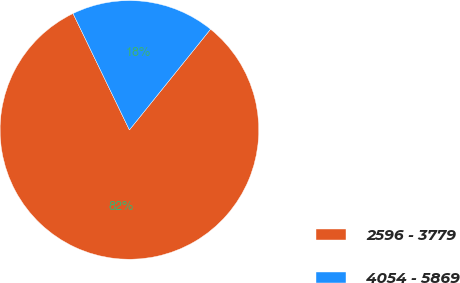Convert chart. <chart><loc_0><loc_0><loc_500><loc_500><pie_chart><fcel>2596 - 3779<fcel>4054 - 5869<nl><fcel>82.03%<fcel>17.97%<nl></chart> 